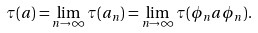<formula> <loc_0><loc_0><loc_500><loc_500>\tau ( a ) = \lim _ { n \to \infty } \tau ( a _ { n } ) = \lim _ { n \to \infty } \tau ( \phi _ { n } a \phi _ { n } ) .</formula> 